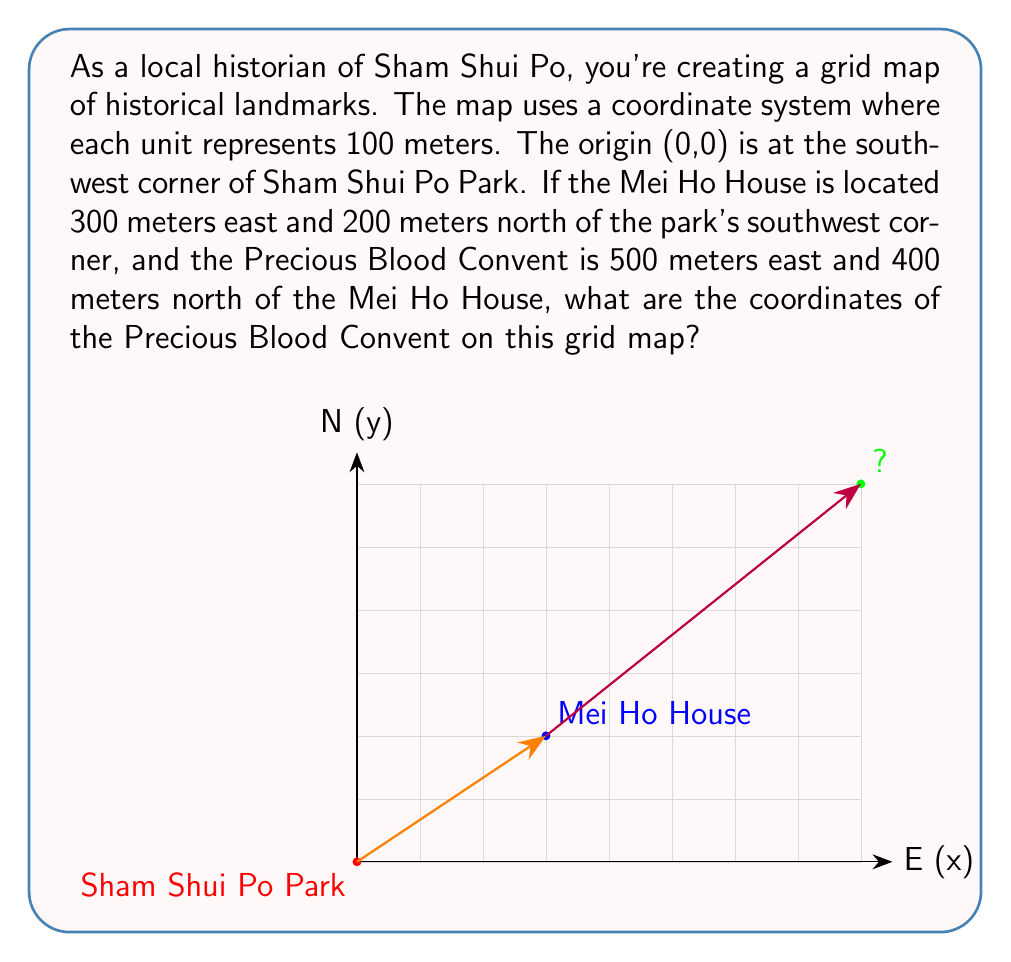Help me with this question. Let's approach this step-by-step:

1) First, let's identify the coordinates of Mei Ho House:
   - It's 300 meters east and 200 meters north of the origin.
   - Each unit on our grid represents 100 meters.
   - So, Mei Ho House is at (3, 2) on our grid.

2) Now, we need to find the position of Precious Blood Convent relative to Mei Ho House:
   - It's 500 meters east and 400 meters north of Mei Ho House.
   - In grid units, that's 5 units east and 4 units north.

3) To get the final coordinates, we add these offsets to Mei Ho House's coordinates:
   - x-coordinate: $3 + 5 = 8$
   - y-coordinate: $2 + 4 = 6$

4) Therefore, the coordinates of Precious Blood Convent are (8, 6).

5) We can verify this:
   - From the origin to Precious Blood Convent is 800 meters east (8 units) and 600 meters north (6 units).
   - This matches our calculation: 300 + 500 = 800 meters east, and 200 + 400 = 600 meters north.
Answer: (8, 6) 